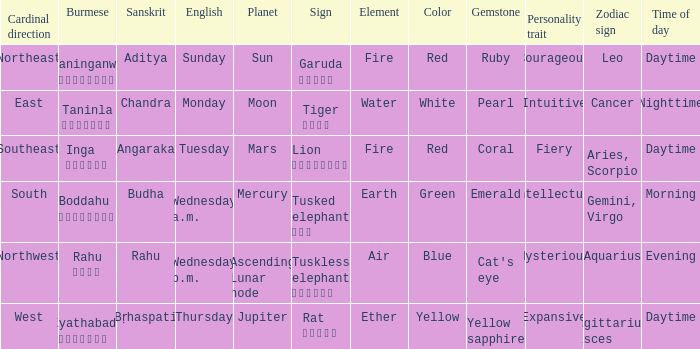State the name of day in english where cardinal direction is east Monday. 